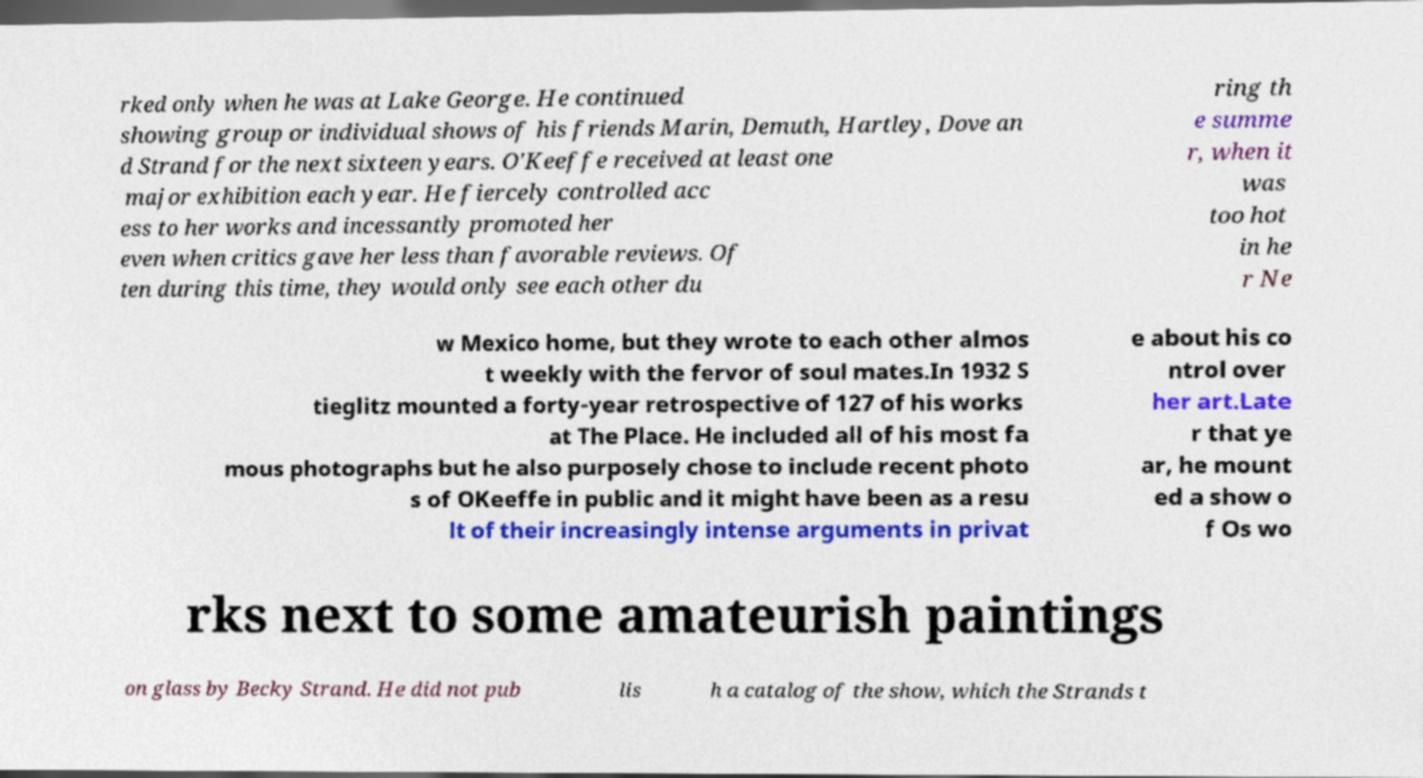Please read and relay the text visible in this image. What does it say? rked only when he was at Lake George. He continued showing group or individual shows of his friends Marin, Demuth, Hartley, Dove an d Strand for the next sixteen years. O'Keeffe received at least one major exhibition each year. He fiercely controlled acc ess to her works and incessantly promoted her even when critics gave her less than favorable reviews. Of ten during this time, they would only see each other du ring th e summe r, when it was too hot in he r Ne w Mexico home, but they wrote to each other almos t weekly with the fervor of soul mates.In 1932 S tieglitz mounted a forty-year retrospective of 127 of his works at The Place. He included all of his most fa mous photographs but he also purposely chose to include recent photo s of OKeeffe in public and it might have been as a resu lt of their increasingly intense arguments in privat e about his co ntrol over her art.Late r that ye ar, he mount ed a show o f Os wo rks next to some amateurish paintings on glass by Becky Strand. He did not pub lis h a catalog of the show, which the Strands t 